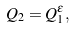Convert formula to latex. <formula><loc_0><loc_0><loc_500><loc_500>Q _ { 2 } = Q _ { 1 } ^ { \epsilon } ,</formula> 